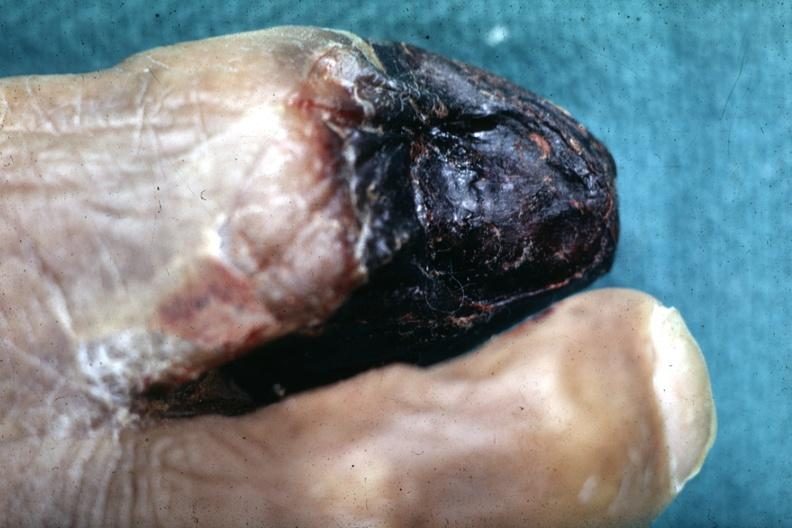s six digits present?
Answer the question using a single word or phrase. No 